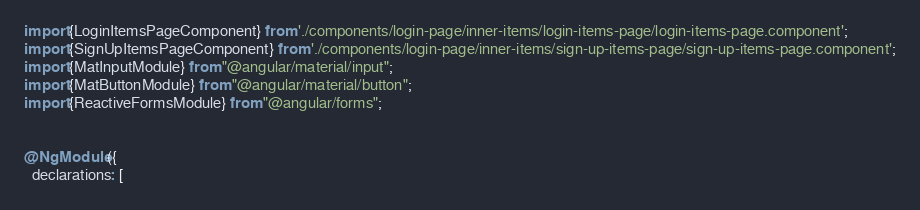<code> <loc_0><loc_0><loc_500><loc_500><_TypeScript_>import {LoginItemsPageComponent} from './components/login-page/inner-items/login-items-page/login-items-page.component';
import {SignUpItemsPageComponent} from './components/login-page/inner-items/sign-up-items-page/sign-up-items-page.component';
import {MatInputModule} from "@angular/material/input";
import {MatButtonModule} from "@angular/material/button";
import {ReactiveFormsModule} from "@angular/forms";


@NgModule({
  declarations: [</code> 